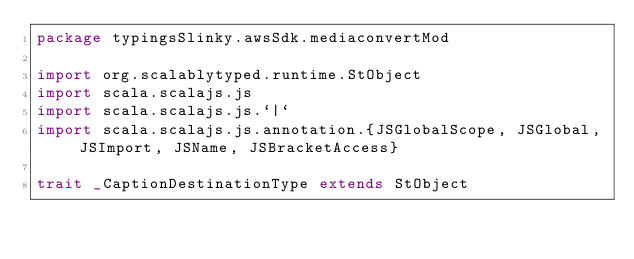Convert code to text. <code><loc_0><loc_0><loc_500><loc_500><_Scala_>package typingsSlinky.awsSdk.mediaconvertMod

import org.scalablytyped.runtime.StObject
import scala.scalajs.js
import scala.scalajs.js.`|`
import scala.scalajs.js.annotation.{JSGlobalScope, JSGlobal, JSImport, JSName, JSBracketAccess}

trait _CaptionDestinationType extends StObject
</code> 